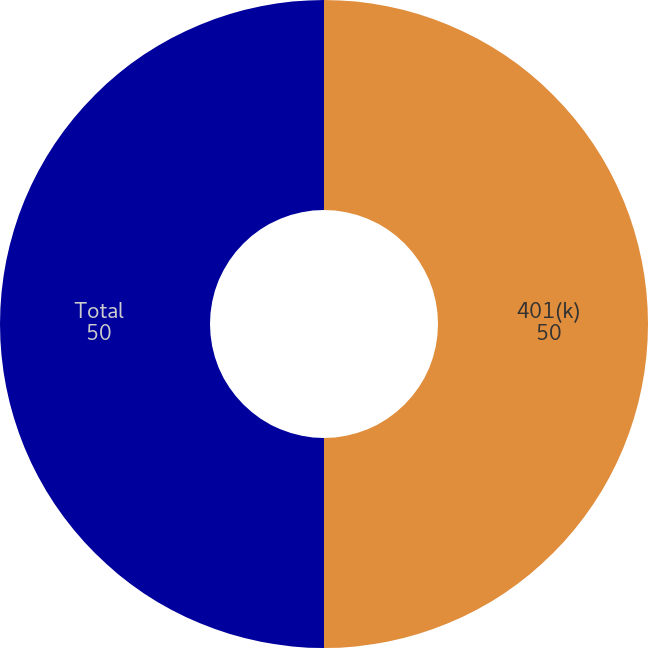<chart> <loc_0><loc_0><loc_500><loc_500><pie_chart><fcel>401(k)<fcel>Total<nl><fcel>50.0%<fcel>50.0%<nl></chart> 